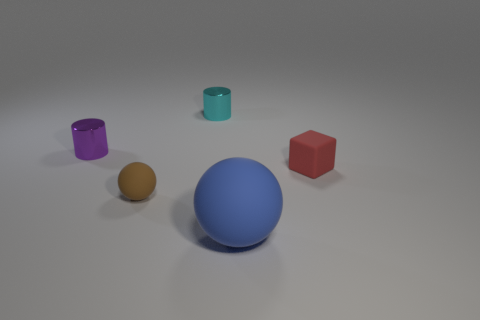There is a object that is on the right side of the small cyan metallic object and left of the red matte thing; what size is it?
Ensure brevity in your answer.  Large. There is a small cylinder that is made of the same material as the cyan object; what color is it?
Your answer should be compact. Purple. What number of purple cylinders are made of the same material as the small cyan object?
Offer a terse response. 1. Are there the same number of red objects that are behind the red rubber block and small cylinders that are behind the tiny matte ball?
Give a very brief answer. No. Do the purple metallic thing and the small rubber thing on the left side of the red thing have the same shape?
Provide a short and direct response. No. Are there any other things that are the same shape as the tiny red matte thing?
Ensure brevity in your answer.  No. Are the small cyan cylinder and the cylinder to the left of the cyan metal object made of the same material?
Ensure brevity in your answer.  Yes. What is the color of the rubber sphere left of the matte ball right of the tiny thing that is in front of the red rubber block?
Offer a very short reply. Brown. Is there any other thing that has the same size as the blue rubber object?
Provide a short and direct response. No. What is the color of the large rubber ball?
Ensure brevity in your answer.  Blue. 